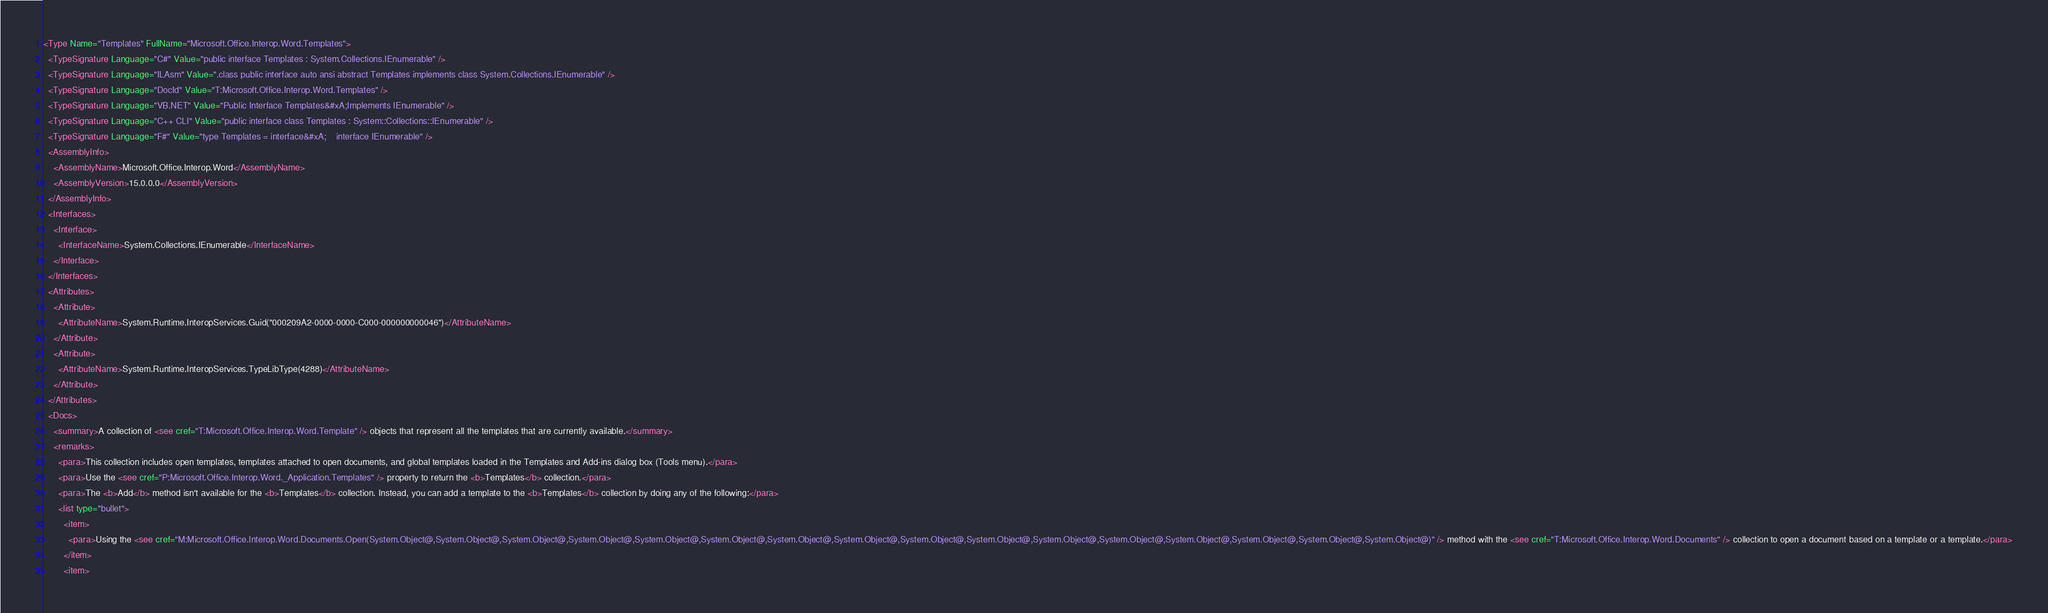<code> <loc_0><loc_0><loc_500><loc_500><_XML_><Type Name="Templates" FullName="Microsoft.Office.Interop.Word.Templates">
  <TypeSignature Language="C#" Value="public interface Templates : System.Collections.IEnumerable" />
  <TypeSignature Language="ILAsm" Value=".class public interface auto ansi abstract Templates implements class System.Collections.IEnumerable" />
  <TypeSignature Language="DocId" Value="T:Microsoft.Office.Interop.Word.Templates" />
  <TypeSignature Language="VB.NET" Value="Public Interface Templates&#xA;Implements IEnumerable" />
  <TypeSignature Language="C++ CLI" Value="public interface class Templates : System::Collections::IEnumerable" />
  <TypeSignature Language="F#" Value="type Templates = interface&#xA;    interface IEnumerable" />
  <AssemblyInfo>
    <AssemblyName>Microsoft.Office.Interop.Word</AssemblyName>
    <AssemblyVersion>15.0.0.0</AssemblyVersion>
  </AssemblyInfo>
  <Interfaces>
    <Interface>
      <InterfaceName>System.Collections.IEnumerable</InterfaceName>
    </Interface>
  </Interfaces>
  <Attributes>
    <Attribute>
      <AttributeName>System.Runtime.InteropServices.Guid("000209A2-0000-0000-C000-000000000046")</AttributeName>
    </Attribute>
    <Attribute>
      <AttributeName>System.Runtime.InteropServices.TypeLibType(4288)</AttributeName>
    </Attribute>
  </Attributes>
  <Docs>
    <summary>A collection of <see cref="T:Microsoft.Office.Interop.Word.Template" /> objects that represent all the templates that are currently available.</summary>
    <remarks>
      <para>This collection includes open templates, templates attached to open documents, and global templates loaded in the Templates and Add-ins dialog box (Tools menu).</para>
      <para>Use the <see cref="P:Microsoft.Office.Interop.Word._Application.Templates" /> property to return the <b>Templates</b> collection.</para>
      <para>The <b>Add</b> method isn't available for the <b>Templates</b> collection. Instead, you can add a template to the <b>Templates</b> collection by doing any of the following:</para>
      <list type="bullet">
        <item>
          <para>Using the <see cref="M:Microsoft.Office.Interop.Word.Documents.Open(System.Object@,System.Object@,System.Object@,System.Object@,System.Object@,System.Object@,System.Object@,System.Object@,System.Object@,System.Object@,System.Object@,System.Object@,System.Object@,System.Object@,System.Object@,System.Object@)" /> method with the <see cref="T:Microsoft.Office.Interop.Word.Documents" /> collection to open a document based on a template or a template.</para>
        </item>
        <item></code> 